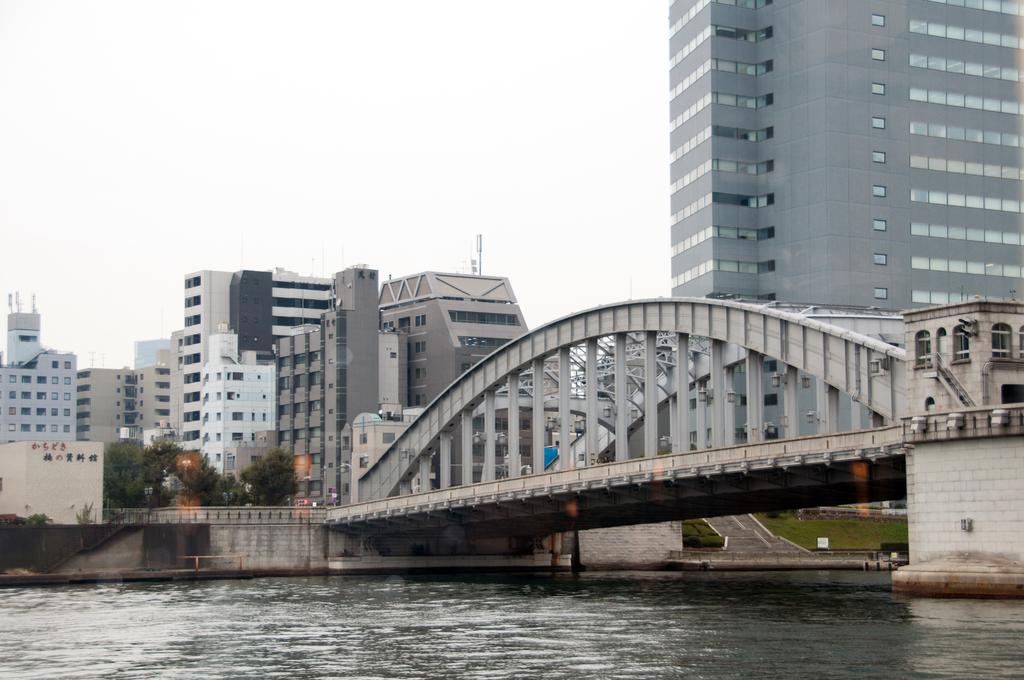What is the main structure featured in the picture? There is a bridge in the picture. What can be seen beneath the bridge? The bridge has water below it. What type of structures can be seen in the background of the picture? There are buildings in the background of the picture. What type of vegetation is visible in the background of the picture? There are trees in the background of the picture. How many legs does the bridge have in the image? Bridges do not have legs; they are supported by other structures, such as pillars or arches. 